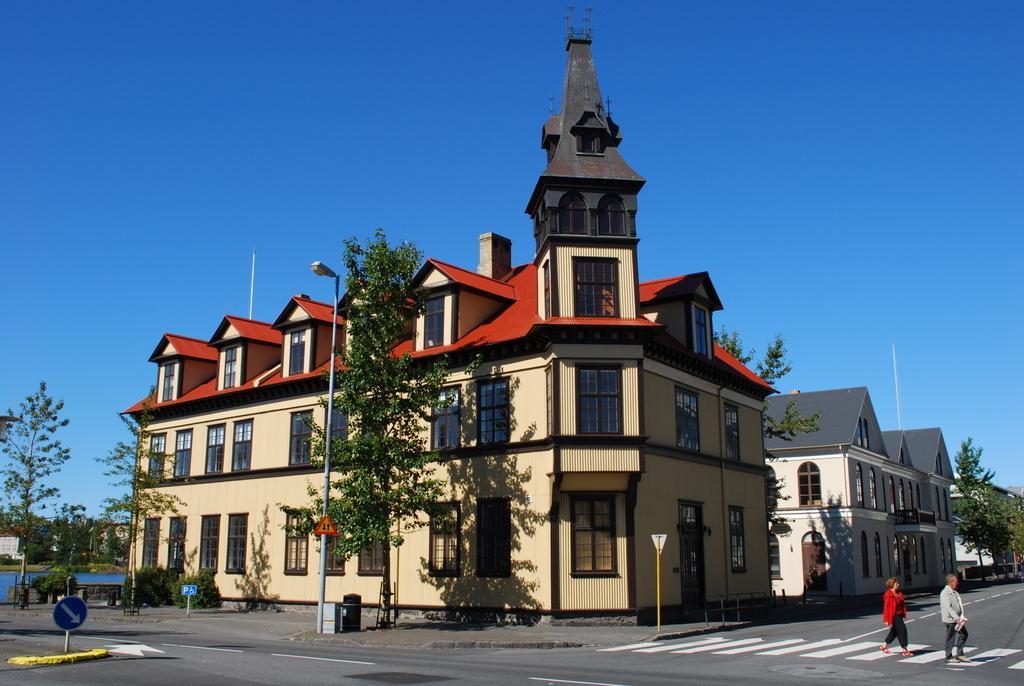Please provide a concise description of this image. At the bottom of the image there is a road. On the road there are zebra crossings. There are two people crossing the zebra crossing. There are poles with sign boards. Behind them there is a footpath with poles and trees. And also there is a bin. There is a building with walls, windows, roofs and also there are pipes. At the top of the image there is a sky. 